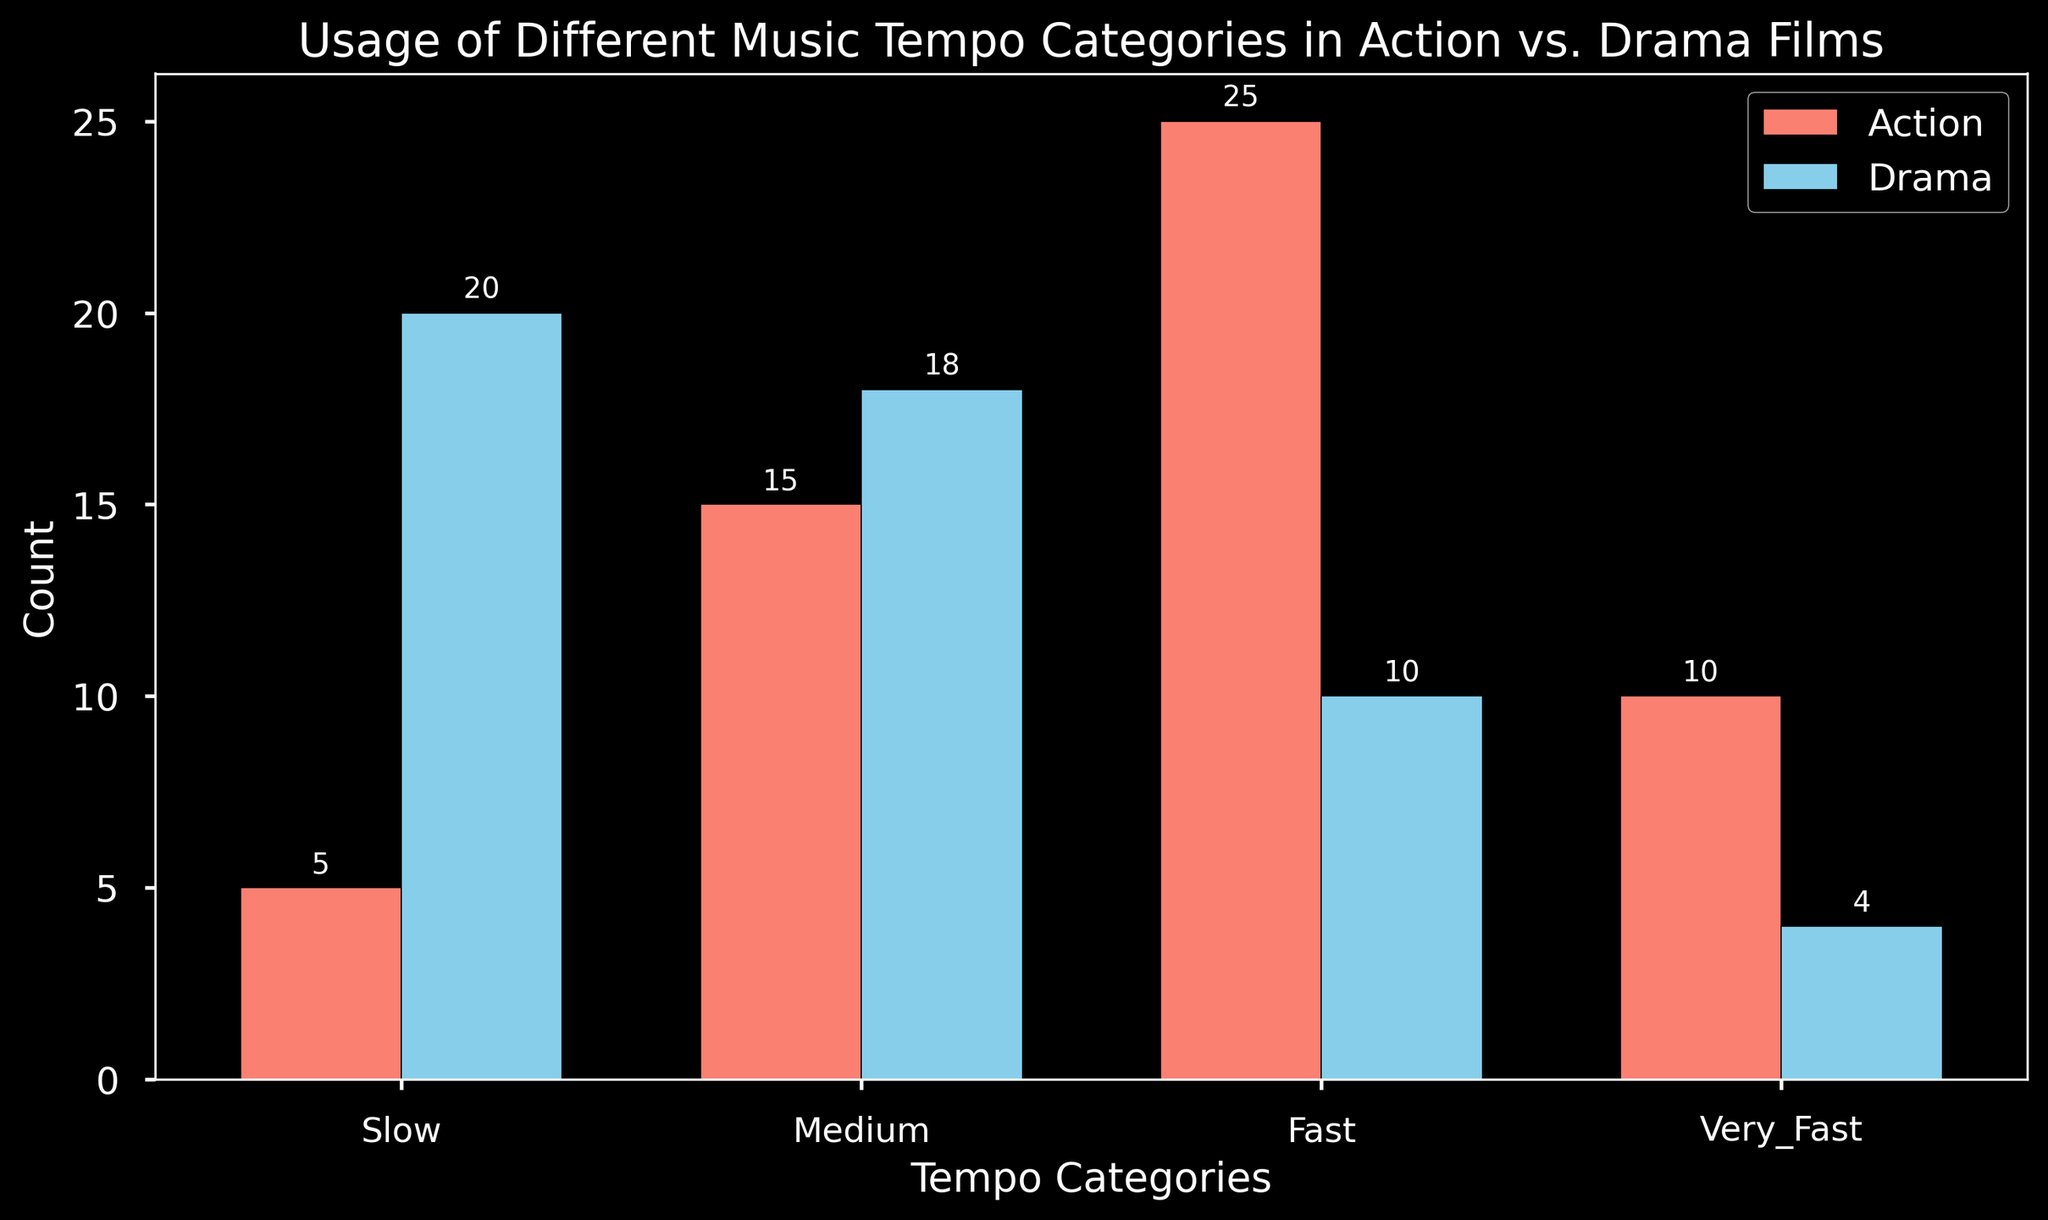Which genre uses the Fast tempo category more frequently? Look at the heights of the bars labeled "Fast" for both Action and Drama. The Action bar is higher than the Drama bar, indicating more frequent use.
Answer: Action What is the difference in count between the Very Fast tempo in Action and Drama films? Compare the heights of the bars for "Very Fast" in Action and Drama. Action has 10 and Drama has 4. The difference is 10 - 4.
Answer: 6 Which genre has the highest count for the Slow tempo category? Look at the bars labeled "Slow" for both genres. The Drama bar is taller than the Action bar.
Answer: Drama How many total tempo counts are there in Drama films? Sum the heights of all the bars for Drama: 20 (Slow) + 18 (Medium) + 10 (Fast) + 4 (Very Fast).
Answer: 52 In which tempo category are the counts equal for both genres? Compare the heights of bars for each tempo category across genres. In the "Medium" category, both Action and Drama have similar heights.
Answer: Medium Which tempo category has the least usage in both genres combined? Look for the shortest bar across all categories. "Very Fast" in Drama has the smallest value (4).
Answer: Very Fast How much more is the usage of Medium tempo in Drama films compared to Fast tempo in Drama films? Compare the heights of the "Medium" and "Fast" bars in Drama. Medium is 18, and Fast is 10. The difference is 18 - 10.
Answer: 8 What is the average count of all tempo categories in Action films? Sum up all the counts for Action and divide by the number of categories: (5+15+25+10)/4.
Answer: 13.75 Which genre has a more balanced distribution of tempo categories? Compare the heights of the bars for each genre. Drama’s heights are more evenly distributed compared to Action.
Answer: Drama What is the total difference in counts between Slow and Very Fast tempos across both genres? Calculate the total counts for Slow (5+20) and Very Fast (10+4). The absolute difference is (5+20) - (10+4).
Answer: 11 